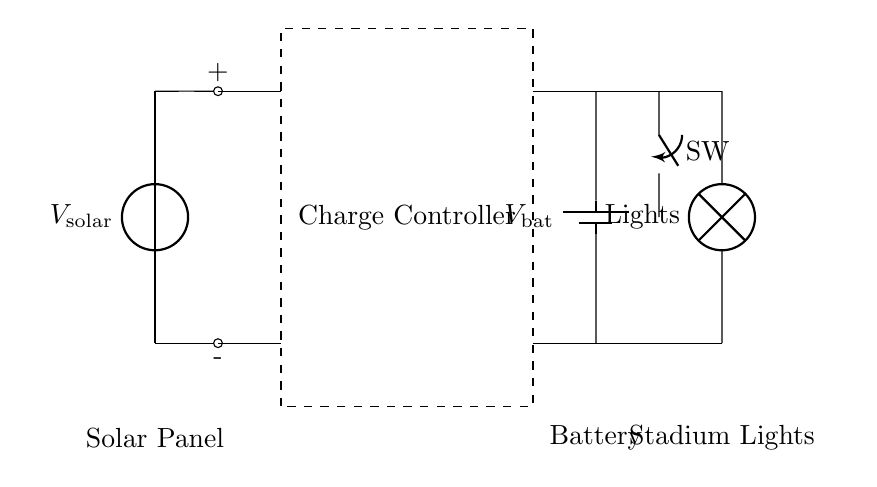What is the main energy source in this circuit? The main energy source is the solar panel, which converts sunlight into electrical energy to power the system.
Answer: Solar panel What component stores energy in the circuit? The component that stores energy is the battery, which accumulates electrical energy generated by the solar panel for later use.
Answer: Battery What is the function of the charge controller? The charge controller regulates the voltage and current coming from the solar panel to the battery, preventing overcharging and ensuring safe operation.
Answer: Regulator How are the stadium lights powered? The stadium lights are powered by the battery, receiving electrical energy stored there to illuminate the area.
Answer: Battery What does the switch do in this circuit? The switch controls the flow of electricity to the stadium lights, allowing them to be turned on or off as needed.
Answer: Control flow What is the potential difference across the solar panel in this circuit? The potential difference across the solar panel is represented as V solar, indicating the voltage generated by the solar energy conversion.
Answer: V solar What role does the lamp play in this circuit? The lamp functions as the load in the circuit, converting electrical energy from the battery into light for illuminating the stadium.
Answer: Lights 